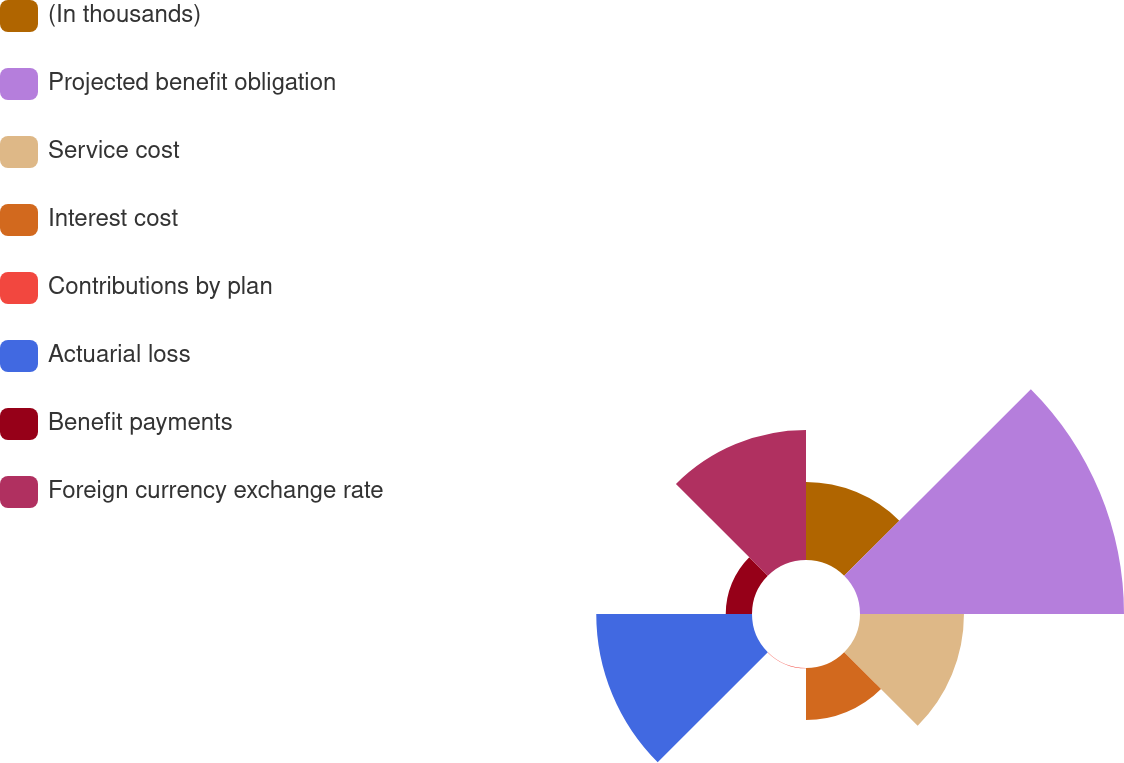<chart> <loc_0><loc_0><loc_500><loc_500><pie_chart><fcel>(In thousands)<fcel>Projected benefit obligation<fcel>Service cost<fcel>Interest cost<fcel>Contributions by plan<fcel>Actuarial loss<fcel>Benefit payments<fcel>Foreign currency exchange rate<nl><fcel>9.63%<fcel>32.58%<fcel>12.83%<fcel>6.43%<fcel>0.04%<fcel>19.22%<fcel>3.24%<fcel>16.03%<nl></chart> 